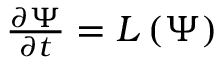Convert formula to latex. <formula><loc_0><loc_0><loc_500><loc_500>\begin{array} { r } { \frac { \partial \Psi } { \partial t } = L \left ( \Psi \right ) } \end{array}</formula> 